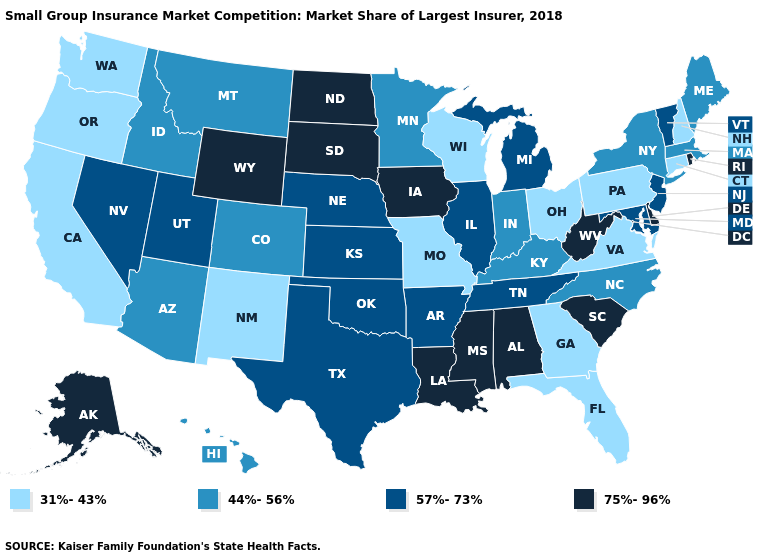Name the states that have a value in the range 57%-73%?
Quick response, please. Arkansas, Illinois, Kansas, Maryland, Michigan, Nebraska, Nevada, New Jersey, Oklahoma, Tennessee, Texas, Utah, Vermont. Does the map have missing data?
Keep it brief. No. Name the states that have a value in the range 44%-56%?
Give a very brief answer. Arizona, Colorado, Hawaii, Idaho, Indiana, Kentucky, Maine, Massachusetts, Minnesota, Montana, New York, North Carolina. Among the states that border New Hampshire , does Massachusetts have the lowest value?
Be succinct. Yes. Does Connecticut have the lowest value in the USA?
Quick response, please. Yes. Name the states that have a value in the range 75%-96%?
Give a very brief answer. Alabama, Alaska, Delaware, Iowa, Louisiana, Mississippi, North Dakota, Rhode Island, South Carolina, South Dakota, West Virginia, Wyoming. Name the states that have a value in the range 44%-56%?
Write a very short answer. Arizona, Colorado, Hawaii, Idaho, Indiana, Kentucky, Maine, Massachusetts, Minnesota, Montana, New York, North Carolina. What is the value of Pennsylvania?
Short answer required. 31%-43%. Is the legend a continuous bar?
Answer briefly. No. What is the lowest value in states that border Rhode Island?
Give a very brief answer. 31%-43%. What is the value of Florida?
Concise answer only. 31%-43%. Name the states that have a value in the range 31%-43%?
Quick response, please. California, Connecticut, Florida, Georgia, Missouri, New Hampshire, New Mexico, Ohio, Oregon, Pennsylvania, Virginia, Washington, Wisconsin. Which states have the lowest value in the USA?
Give a very brief answer. California, Connecticut, Florida, Georgia, Missouri, New Hampshire, New Mexico, Ohio, Oregon, Pennsylvania, Virginia, Washington, Wisconsin. Does the first symbol in the legend represent the smallest category?
Keep it brief. Yes. What is the value of Florida?
Give a very brief answer. 31%-43%. 